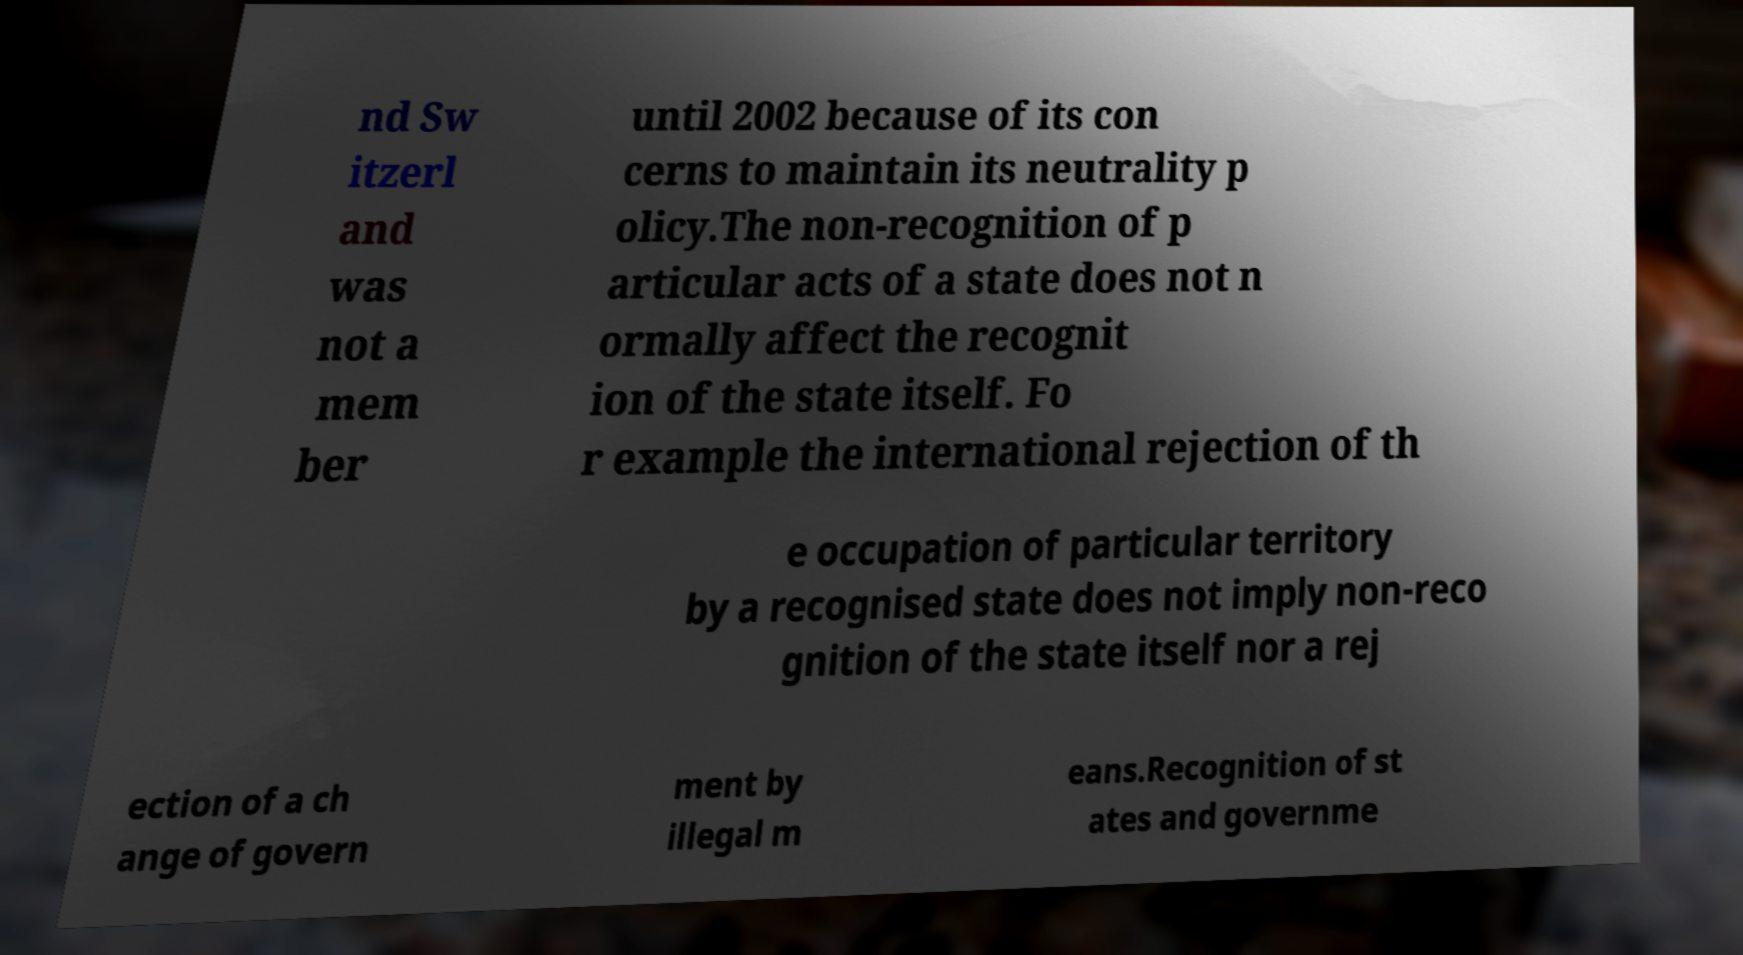I need the written content from this picture converted into text. Can you do that? nd Sw itzerl and was not a mem ber until 2002 because of its con cerns to maintain its neutrality p olicy.The non-recognition of p articular acts of a state does not n ormally affect the recognit ion of the state itself. Fo r example the international rejection of th e occupation of particular territory by a recognised state does not imply non-reco gnition of the state itself nor a rej ection of a ch ange of govern ment by illegal m eans.Recognition of st ates and governme 